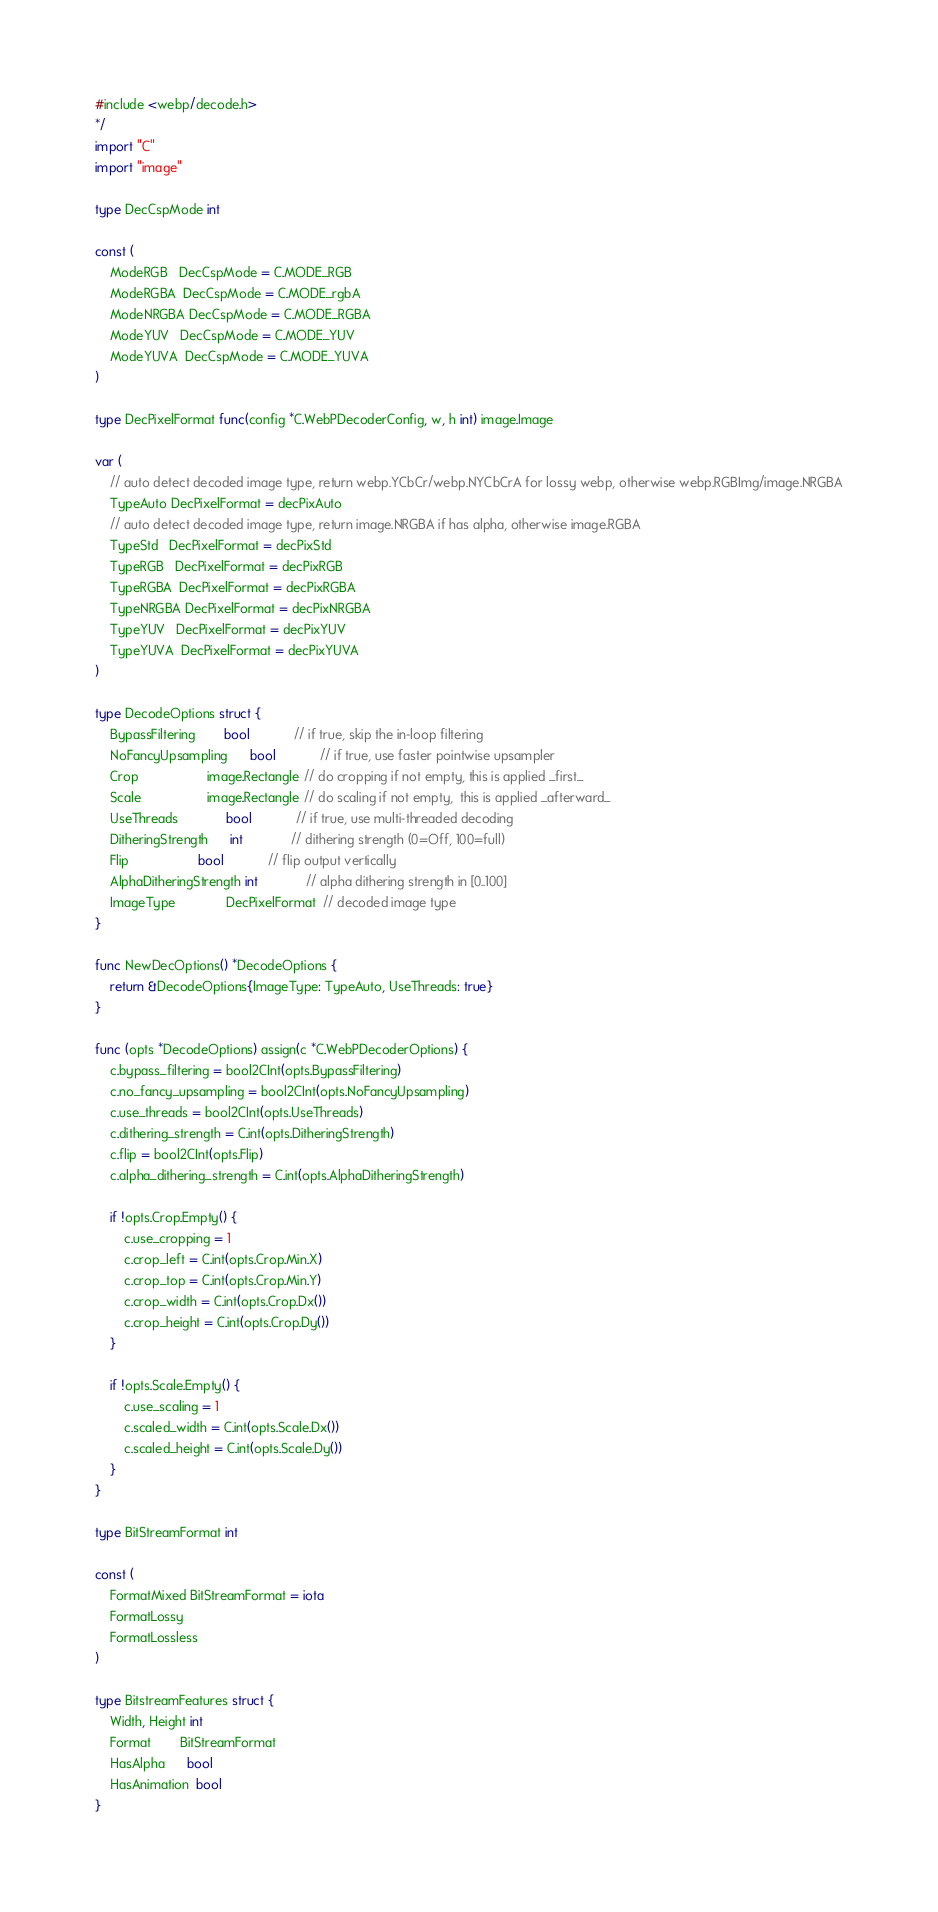<code> <loc_0><loc_0><loc_500><loc_500><_Go_>#include <webp/decode.h>
*/
import "C"
import "image"

type DecCspMode int

const (
	ModeRGB   DecCspMode = C.MODE_RGB
	ModeRGBA  DecCspMode = C.MODE_rgbA
	ModeNRGBA DecCspMode = C.MODE_RGBA
	ModeYUV   DecCspMode = C.MODE_YUV
	ModeYUVA  DecCspMode = C.MODE_YUVA
)

type DecPixelFormat func(config *C.WebPDecoderConfig, w, h int) image.Image

var (
	// auto detect decoded image type, return webp.YCbCr/webp.NYCbCrA for lossy webp, otherwise webp.RGBImg/image.NRGBA
	TypeAuto DecPixelFormat = decPixAuto
	// auto detect decoded image type, return image.NRGBA if has alpha, otherwise image.RGBA
	TypeStd   DecPixelFormat = decPixStd
	TypeRGB   DecPixelFormat = decPixRGB
	TypeRGBA  DecPixelFormat = decPixRGBA
	TypeNRGBA DecPixelFormat = decPixNRGBA
	TypeYUV   DecPixelFormat = decPixYUV
	TypeYUVA  DecPixelFormat = decPixYUVA
)

type DecodeOptions struct {
	BypassFiltering        bool            // if true, skip the in-loop filtering
	NoFancyUpsampling      bool            // if true, use faster pointwise upsampler
	Crop                   image.Rectangle // do cropping if not empty, this is applied _first_
	Scale                  image.Rectangle // do scaling if not empty,  this is applied _afterward_
	UseThreads             bool            // if true, use multi-threaded decoding
	DitheringStrength      int             // dithering strength (0=Off, 100=full)
	Flip                   bool            // flip output vertically
	AlphaDitheringStrength int             // alpha dithering strength in [0..100]
	ImageType              DecPixelFormat  // decoded image type
}

func NewDecOptions() *DecodeOptions {
	return &DecodeOptions{ImageType: TypeAuto, UseThreads: true}
}

func (opts *DecodeOptions) assign(c *C.WebPDecoderOptions) {
	c.bypass_filtering = bool2CInt(opts.BypassFiltering)
	c.no_fancy_upsampling = bool2CInt(opts.NoFancyUpsampling)
	c.use_threads = bool2CInt(opts.UseThreads)
	c.dithering_strength = C.int(opts.DitheringStrength)
	c.flip = bool2CInt(opts.Flip)
	c.alpha_dithering_strength = C.int(opts.AlphaDitheringStrength)

	if !opts.Crop.Empty() {
		c.use_cropping = 1
		c.crop_left = C.int(opts.Crop.Min.X)
		c.crop_top = C.int(opts.Crop.Min.Y)
		c.crop_width = C.int(opts.Crop.Dx())
		c.crop_height = C.int(opts.Crop.Dy())
	}

	if !opts.Scale.Empty() {
		c.use_scaling = 1
		c.scaled_width = C.int(opts.Scale.Dx())
		c.scaled_height = C.int(opts.Scale.Dy())
	}
}

type BitStreamFormat int

const (
	FormatMixed BitStreamFormat = iota
	FormatLossy
	FormatLossless
)

type BitstreamFeatures struct {
	Width, Height int
	Format        BitStreamFormat
	HasAlpha      bool
	HasAnimation  bool
}
</code> 